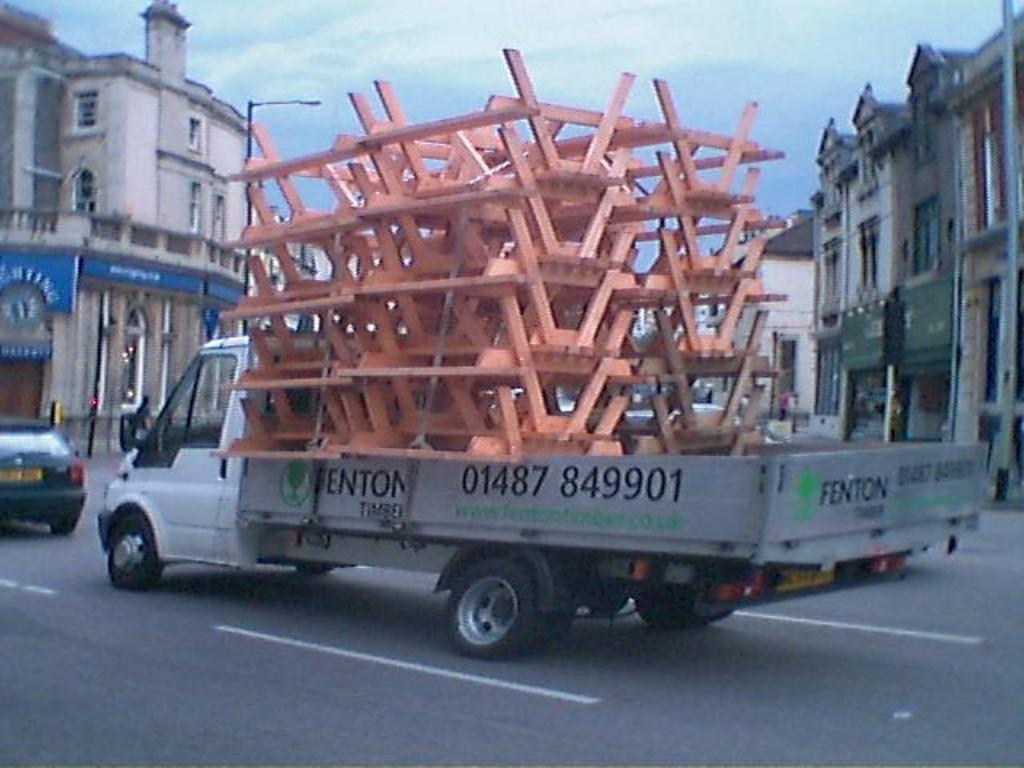What type of vehicle is in the image? There is a white color van in the image. What is inside the van? The van is full of orange color metal rods. What is the van doing in the image? The van is moving on the road. What can be seen in the background of the image? There are buildings visible in the background of the image. What is visible in the sky in the image? The sky is visible in the image, and clouds are present. How many apples are being thought about by the light in the image? There is no light or apples present in the image, so it is not possible to answer that question. 